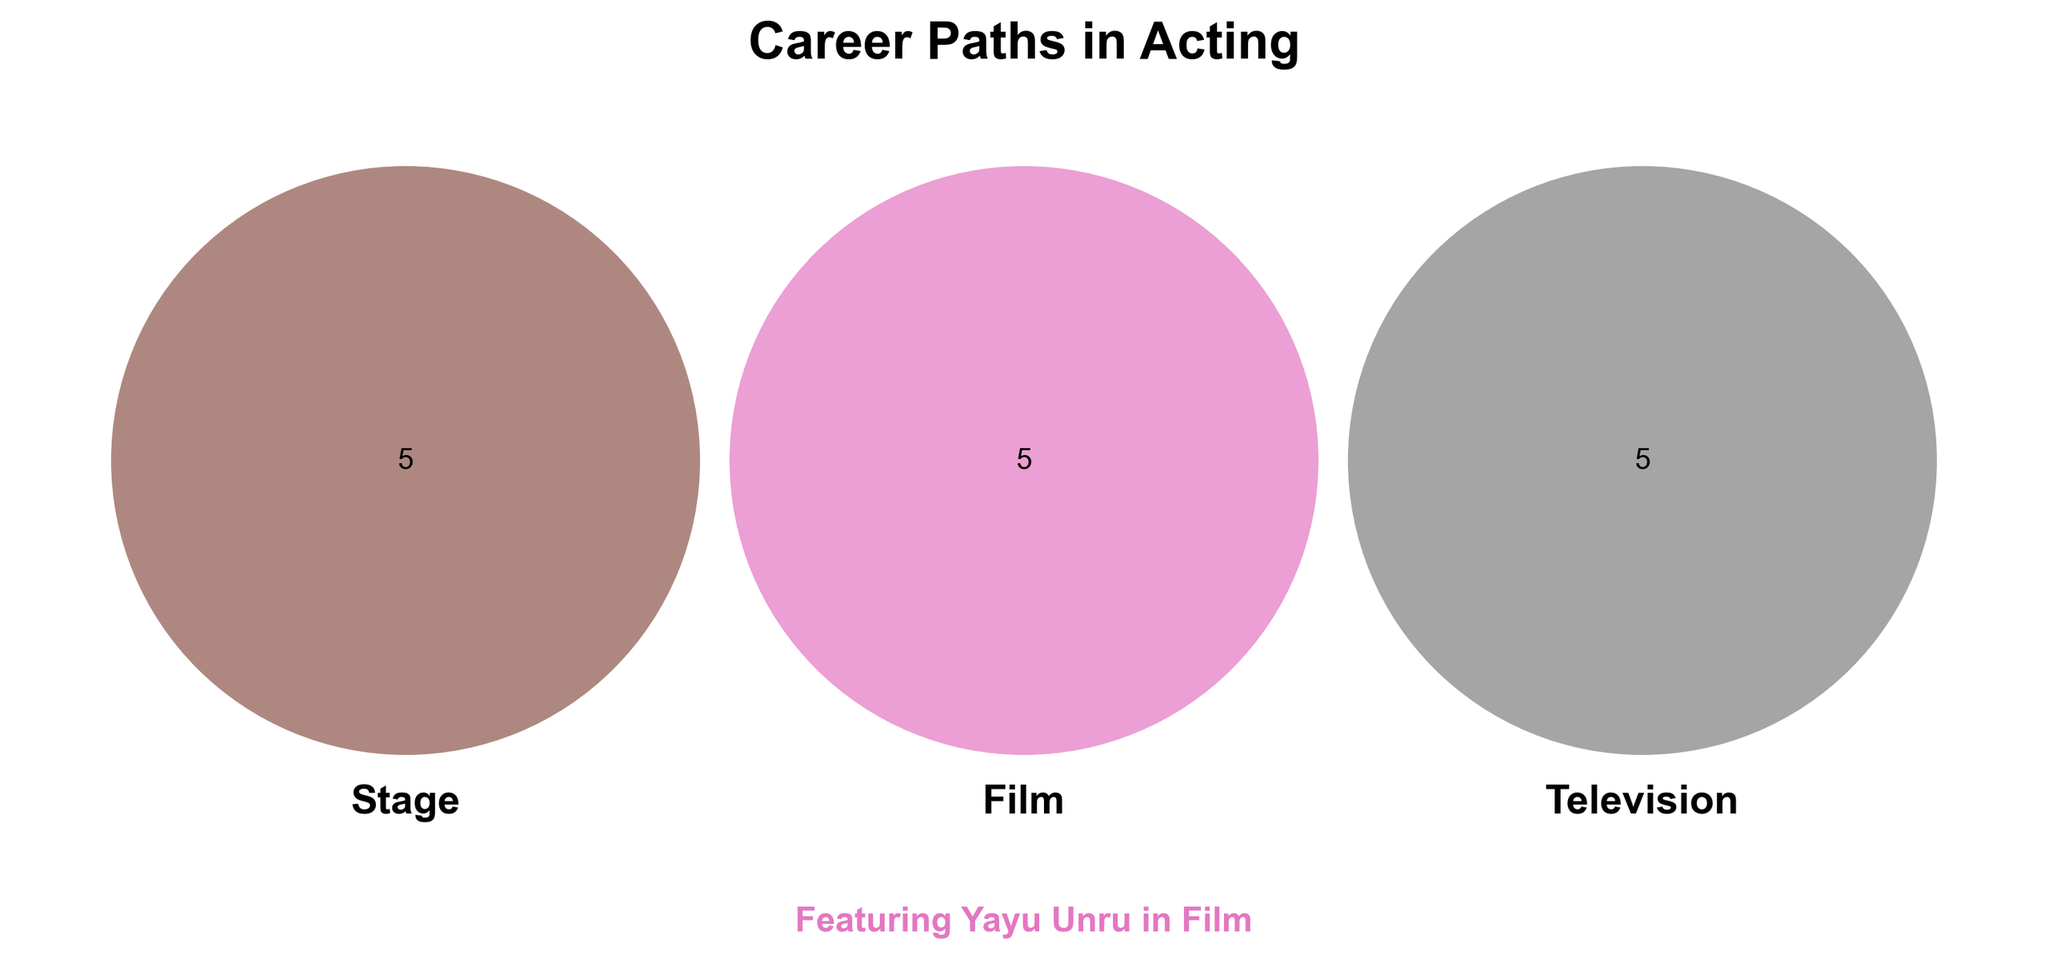Which sector is highlighted for Yayu Unru? The text mentioning Yayu Unru in the plot emphasizes his role in one particular sector. "Featuring Yayu Unru in Film" suggests that Yayu Unru is noted for his work in the film sector.
Answer: Film How many career paths are common to all three sectors? Look at the section where all three circles (Stage, Film, Television) overlap and count the items listed there. The items inside the overlapping section of all three sectors are "Acting classes", "Auditions", "Agents", "Networking", and "Social media".
Answer: 5 What career paths are unique to the film sector? Review only the space within the Film circle that doesn’t overlap with Stage or Television. The career paths listed there are "Yayu Unru", "Hollywood", "Indie films", "Action movies", and "Film festivals".
Answer: Yayu Unru, Hollywood, Indie films, Action movies, Film festivals How many career paths are shared between Stage and Television but not Film? The items in the overlap between Stage and Television circles excluding Film are zero since there is no area intersecting both Stage and Television only.
Answer: 0 Which sector includes improvisation as a career path? Check which circle contains the text "Improv." It is located within the Stage circle.
Answer: Stage Are there more unique career paths in Film or Television? Count the unique items within each individual circle for Film and Television respectively. Film has "Yayu Unru", "Hollywood", "Indie films", "Action movies", and "Film festivals", totaling 5. Television has "Soap operas", "Sitcoms", "Commercials", "Reality shows", and "Talk shows", which also totals 5.
Answer: Equal What is common between Stage and Film but not Television? Identify items present in the overlapping area between Stage and Film but not in Television. There are none as there is no such specific section displayed in the figure.
Answer: None How many career paths are unique to Stage? Count the career paths that are inside the Stage circle but not overlapping with Film or Television. The career paths listed inside Stage are "Shakespeare", "Broadway", "Musicals", "Improv", and "Monologues".
Answer: 5 